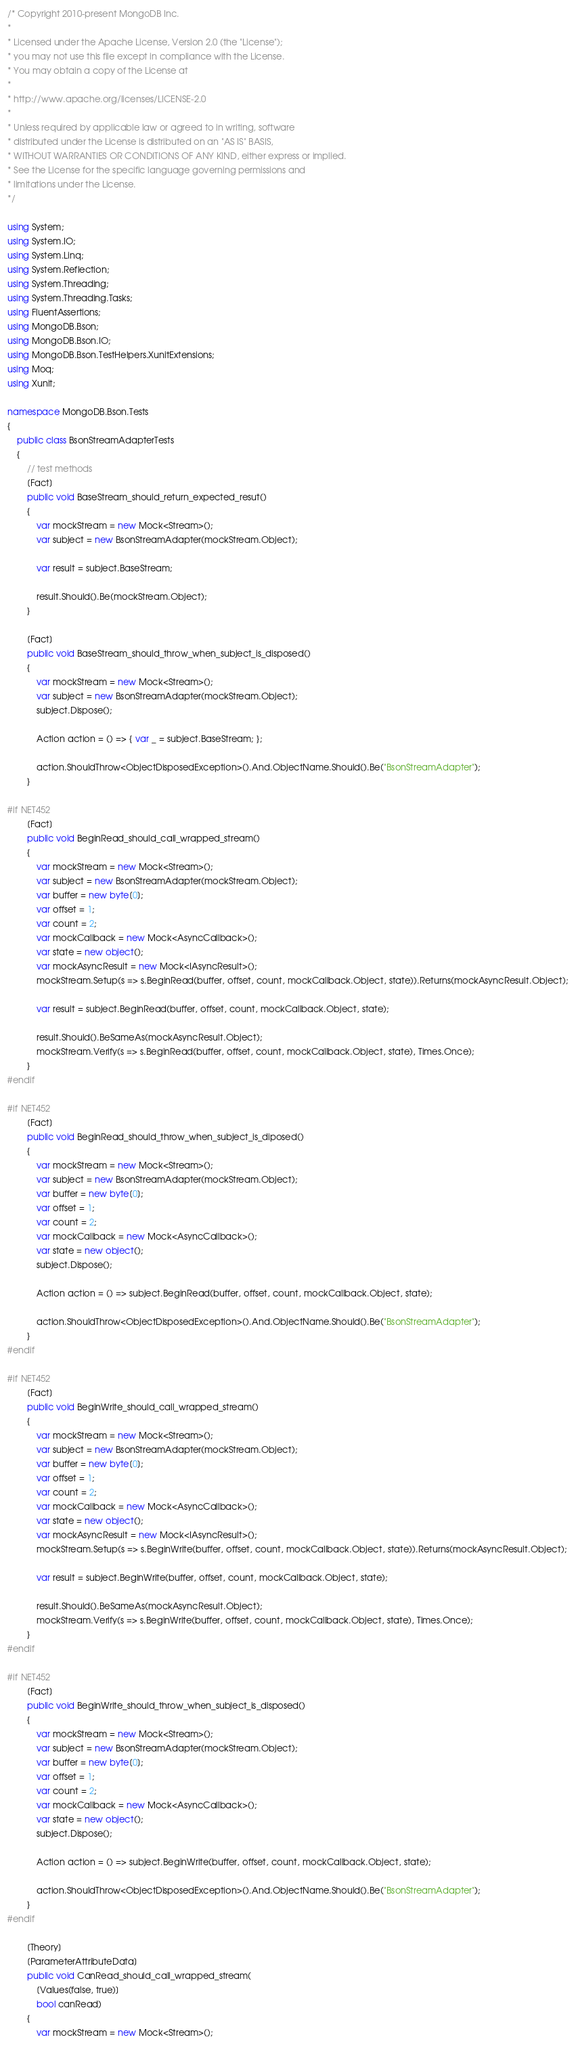Convert code to text. <code><loc_0><loc_0><loc_500><loc_500><_C#_>/* Copyright 2010-present MongoDB Inc.
*
* Licensed under the Apache License, Version 2.0 (the "License");
* you may not use this file except in compliance with the License.
* You may obtain a copy of the License at
*
* http://www.apache.org/licenses/LICENSE-2.0
*
* Unless required by applicable law or agreed to in writing, software
* distributed under the License is distributed on an "AS IS" BASIS,
* WITHOUT WARRANTIES OR CONDITIONS OF ANY KIND, either express or implied.
* See the License for the specific language governing permissions and
* limitations under the License.
*/

using System;
using System.IO;
using System.Linq;
using System.Reflection;
using System.Threading;
using System.Threading.Tasks;
using FluentAssertions;
using MongoDB.Bson;
using MongoDB.Bson.IO;
using MongoDB.Bson.TestHelpers.XunitExtensions;
using Moq;
using Xunit;

namespace MongoDB.Bson.Tests
{
    public class BsonStreamAdapterTests
    {
        // test methods
        [Fact]
        public void BaseStream_should_return_expected_resut()
        {
            var mockStream = new Mock<Stream>();
            var subject = new BsonStreamAdapter(mockStream.Object);

            var result = subject.BaseStream;

            result.Should().Be(mockStream.Object);
        }

        [Fact]
        public void BaseStream_should_throw_when_subject_is_disposed()
        {
            var mockStream = new Mock<Stream>();
            var subject = new BsonStreamAdapter(mockStream.Object);
            subject.Dispose();

            Action action = () => { var _ = subject.BaseStream; };

            action.ShouldThrow<ObjectDisposedException>().And.ObjectName.Should().Be("BsonStreamAdapter");
        }

#if NET452
        [Fact]
        public void BeginRead_should_call_wrapped_stream()
        {
            var mockStream = new Mock<Stream>();
            var subject = new BsonStreamAdapter(mockStream.Object);
            var buffer = new byte[0];
            var offset = 1;
            var count = 2;
            var mockCallback = new Mock<AsyncCallback>();
            var state = new object();
            var mockAsyncResult = new Mock<IAsyncResult>();
            mockStream.Setup(s => s.BeginRead(buffer, offset, count, mockCallback.Object, state)).Returns(mockAsyncResult.Object);

            var result = subject.BeginRead(buffer, offset, count, mockCallback.Object, state);

            result.Should().BeSameAs(mockAsyncResult.Object);
            mockStream.Verify(s => s.BeginRead(buffer, offset, count, mockCallback.Object, state), Times.Once);
        }
#endif

#if NET452
        [Fact]
        public void BeginRead_should_throw_when_subject_is_diposed()
        {
            var mockStream = new Mock<Stream>();
            var subject = new BsonStreamAdapter(mockStream.Object);
            var buffer = new byte[0];
            var offset = 1;
            var count = 2;
            var mockCallback = new Mock<AsyncCallback>();
            var state = new object();
            subject.Dispose();

            Action action = () => subject.BeginRead(buffer, offset, count, mockCallback.Object, state);

            action.ShouldThrow<ObjectDisposedException>().And.ObjectName.Should().Be("BsonStreamAdapter");
        }
#endif

#if NET452
        [Fact]
        public void BeginWrite_should_call_wrapped_stream()
        {
            var mockStream = new Mock<Stream>();
            var subject = new BsonStreamAdapter(mockStream.Object);
            var buffer = new byte[0];
            var offset = 1;
            var count = 2;
            var mockCallback = new Mock<AsyncCallback>();
            var state = new object();
            var mockAsyncResult = new Mock<IAsyncResult>();
            mockStream.Setup(s => s.BeginWrite(buffer, offset, count, mockCallback.Object, state)).Returns(mockAsyncResult.Object);

            var result = subject.BeginWrite(buffer, offset, count, mockCallback.Object, state);

            result.Should().BeSameAs(mockAsyncResult.Object);
            mockStream.Verify(s => s.BeginWrite(buffer, offset, count, mockCallback.Object, state), Times.Once);
        }
#endif

#if NET452
        [Fact]
        public void BeginWrite_should_throw_when_subject_is_disposed()
        {
            var mockStream = new Mock<Stream>();
            var subject = new BsonStreamAdapter(mockStream.Object);
            var buffer = new byte[0];
            var offset = 1;
            var count = 2;
            var mockCallback = new Mock<AsyncCallback>();
            var state = new object();
            subject.Dispose();

            Action action = () => subject.BeginWrite(buffer, offset, count, mockCallback.Object, state);

            action.ShouldThrow<ObjectDisposedException>().And.ObjectName.Should().Be("BsonStreamAdapter");
        }
#endif

        [Theory]
        [ParameterAttributeData]
        public void CanRead_should_call_wrapped_stream(
            [Values(false, true)]
            bool canRead)
        {
            var mockStream = new Mock<Stream>();</code> 